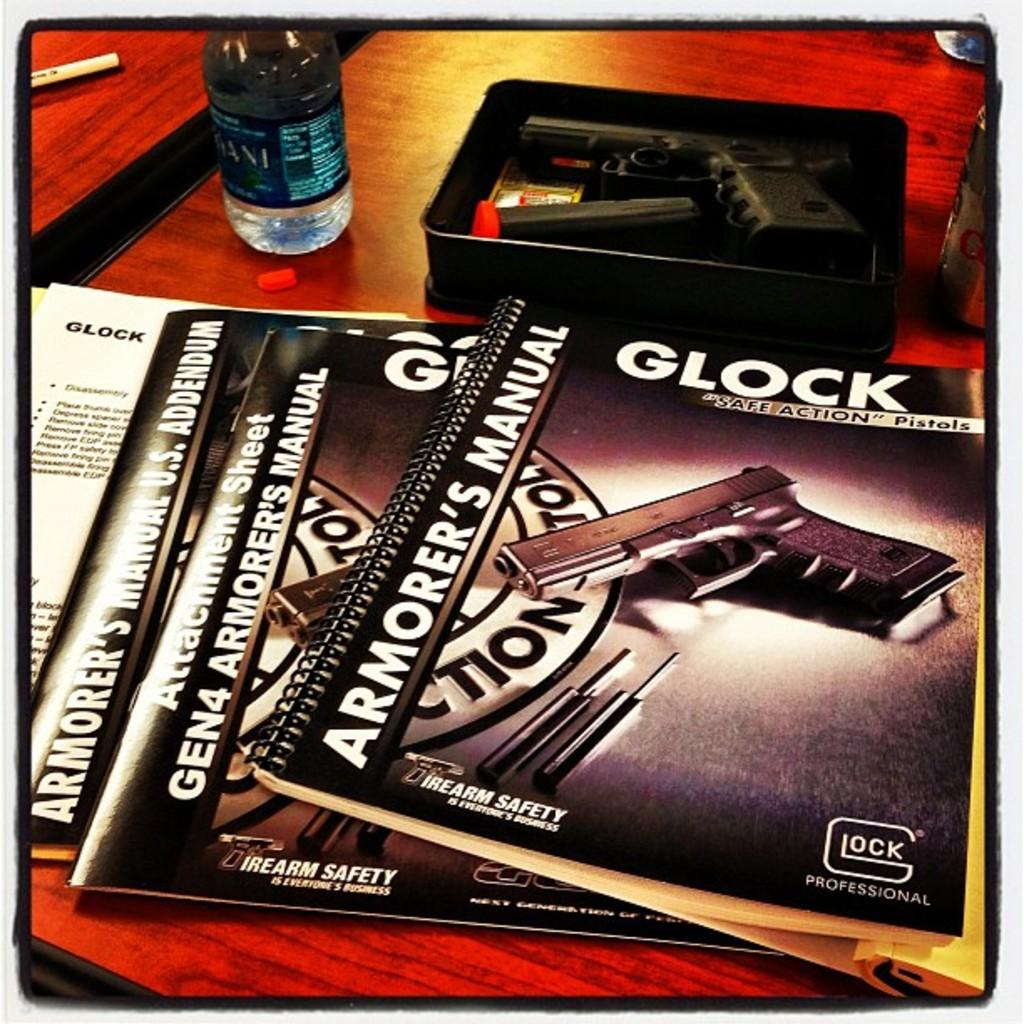What piece of furniture is present in the image? There is a table in the image. What items can be seen on the table? There are magazines, a bottle, and a gun in a box on the table. Can you describe the type of container for the gun? The gun is in a box on the table. How many women are painting on the canvas in the image? There is no canvas or women present in the image. What type of bird can be seen flying near the gun? There are no birds present in the image. 